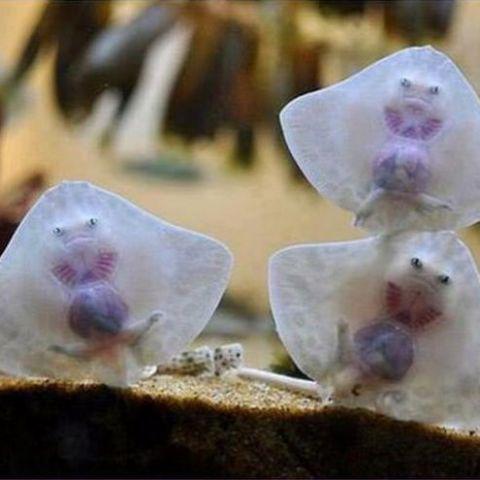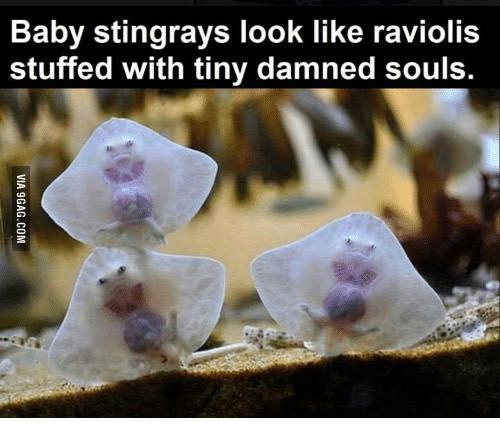The first image is the image on the left, the second image is the image on the right. Given the left and right images, does the statement "The left and right image contains a total of five stingrays." hold true? Answer yes or no. No. The first image is the image on the left, the second image is the image on the right. For the images displayed, is the sentence "The left image contains just one stingray." factually correct? Answer yes or no. No. 